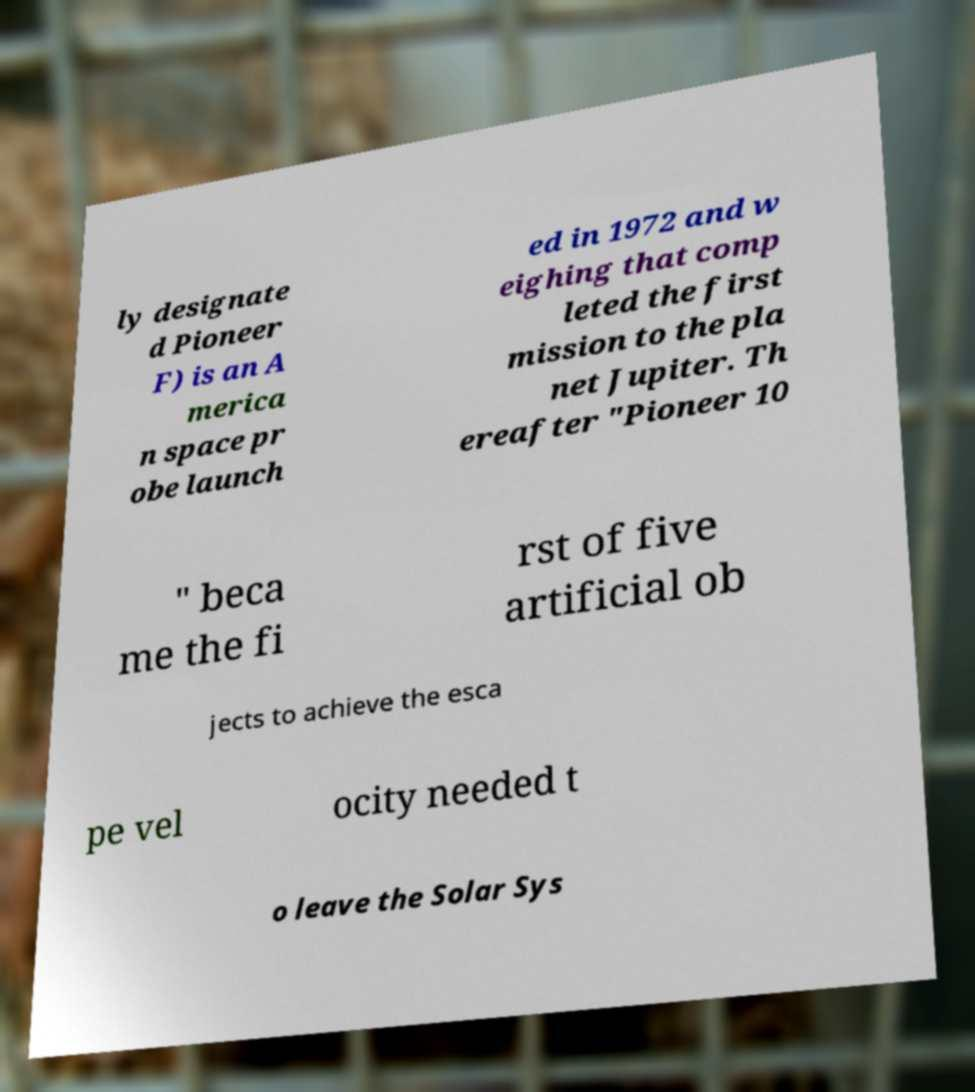What messages or text are displayed in this image? I need them in a readable, typed format. ly designate d Pioneer F) is an A merica n space pr obe launch ed in 1972 and w eighing that comp leted the first mission to the pla net Jupiter. Th ereafter "Pioneer 10 " beca me the fi rst of five artificial ob jects to achieve the esca pe vel ocity needed t o leave the Solar Sys 